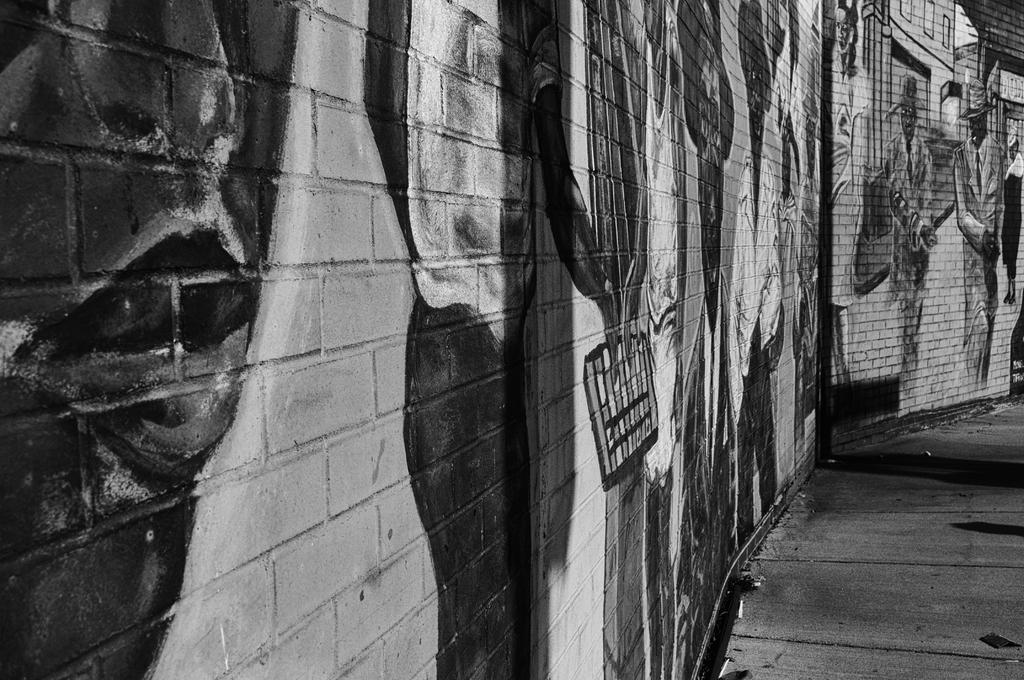Please provide a concise description of this image. This is a black and white picture. This picture contains the graffiti. In the right bottom of the picture, we see the pavement. 